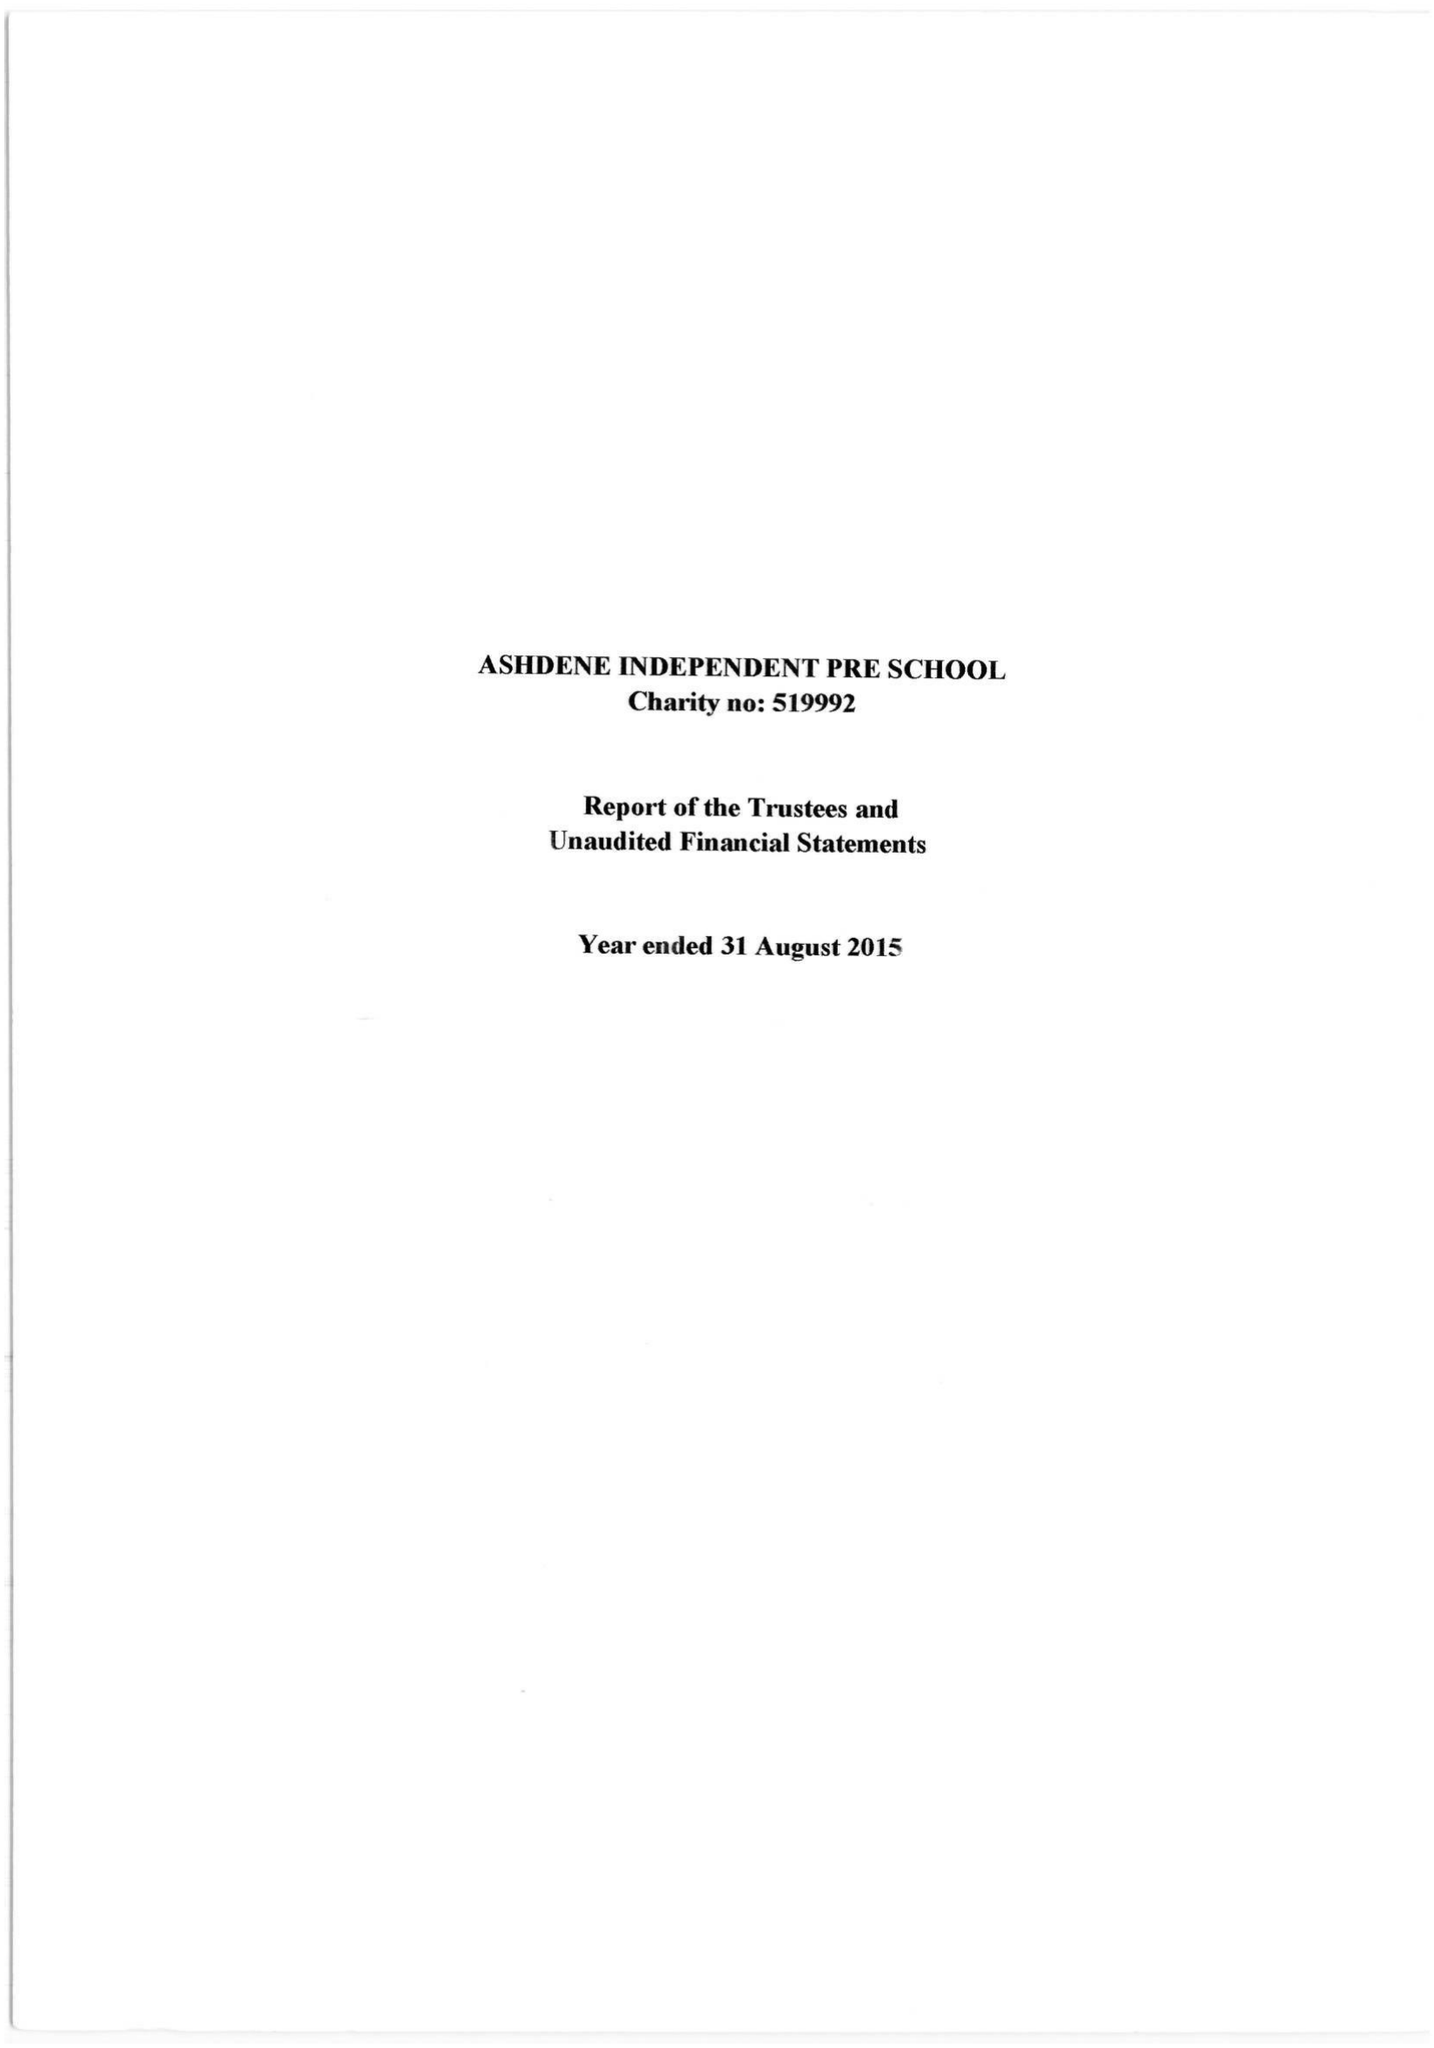What is the value for the income_annually_in_british_pounds?
Answer the question using a single word or phrase. 188110.00 